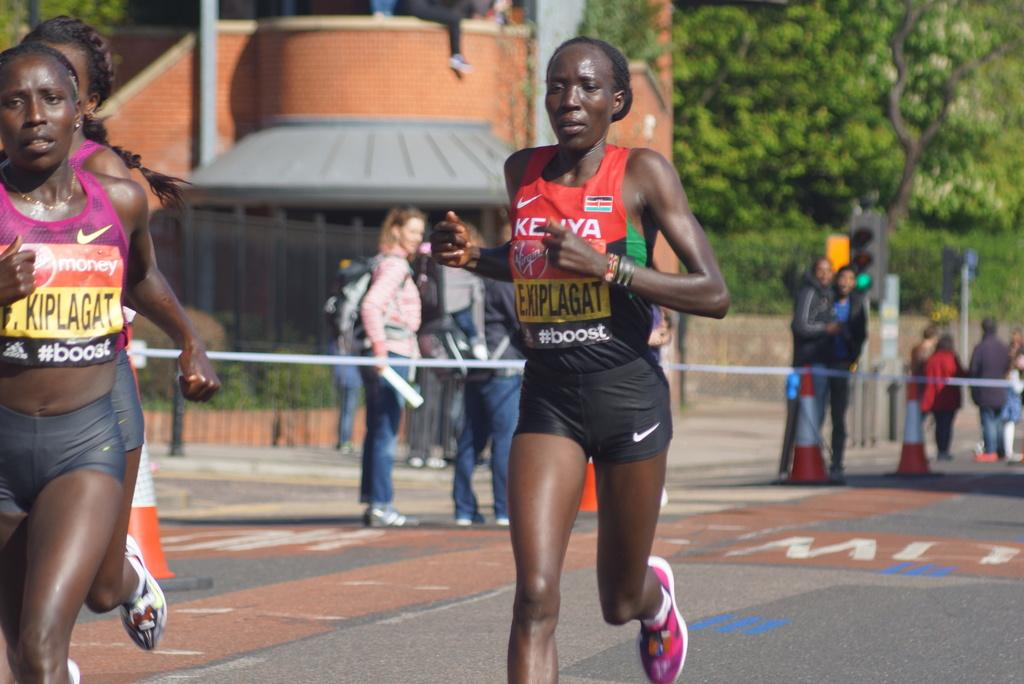What is happening with the group of people in the image? Some people are running, while others are standing on a path in the image. Can you describe the location of the people in the image? The people are on a path, and there is a fence visible in the image. What can be seen in the background of the image? There is a building and trees in the background of the image. What type of iron is being used by the people in the image? There is no iron present in the image; the people are running and standing on a path. How many matches are visible in the image? There are no matches present in the image; it features a group of people, a fence, a path, a building, and trees in the background. 